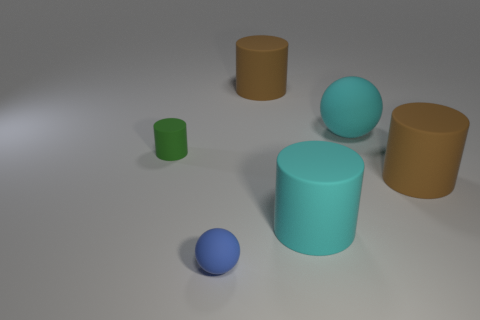The large thing that is the same color as the large sphere is what shape?
Your answer should be very brief. Cylinder. What is the size of the rubber cylinder that is the same color as the big sphere?
Give a very brief answer. Large. There is a tiny matte thing in front of the cylinder that is on the left side of the small blue ball; how many cylinders are on the left side of it?
Your response must be concise. 1. What is the color of the tiny object that is behind the blue sphere?
Your response must be concise. Green. Do the ball left of the cyan matte ball and the tiny matte cylinder have the same color?
Offer a terse response. No. There is a cyan object that is the same shape as the green rubber thing; what is its size?
Your response must be concise. Large. Are there any other things that are the same size as the blue rubber thing?
Provide a short and direct response. Yes. What material is the brown object right of the brown matte cylinder left of the brown cylinder that is right of the cyan matte sphere made of?
Provide a succinct answer. Rubber. Are there more brown objects behind the big cyan rubber ball than tiny blue matte objects that are behind the cyan rubber cylinder?
Offer a terse response. Yes. Do the cyan matte cylinder and the green cylinder have the same size?
Your response must be concise. No. 